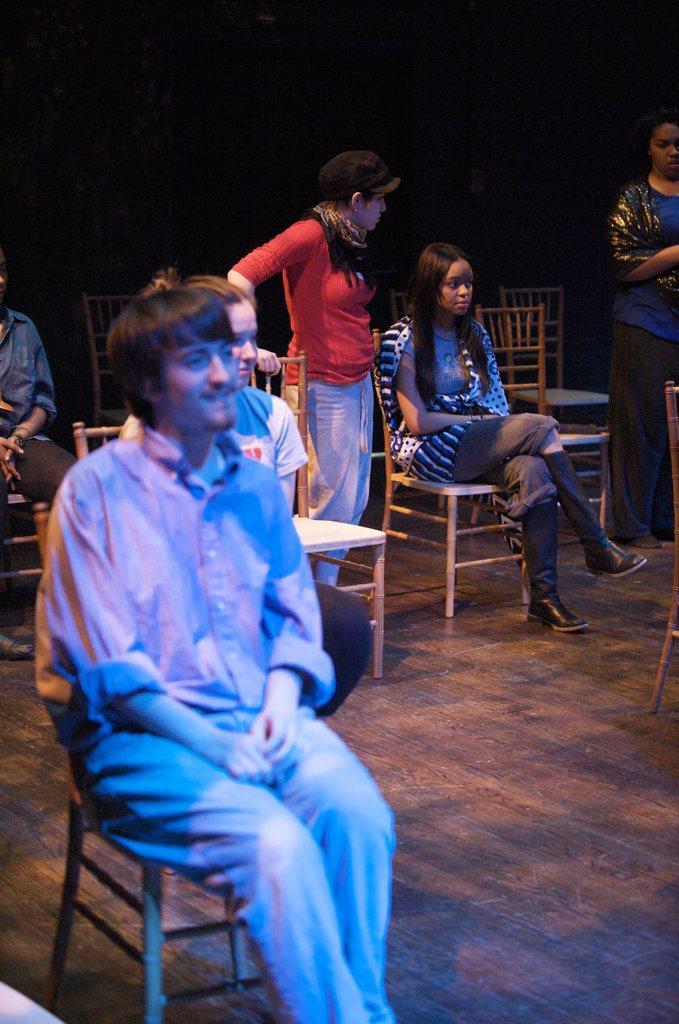Could you give a brief overview of what you see in this image? There are few people sitting on the chairs and two people standing. This looks like a wooden floor. The background looks dark. 